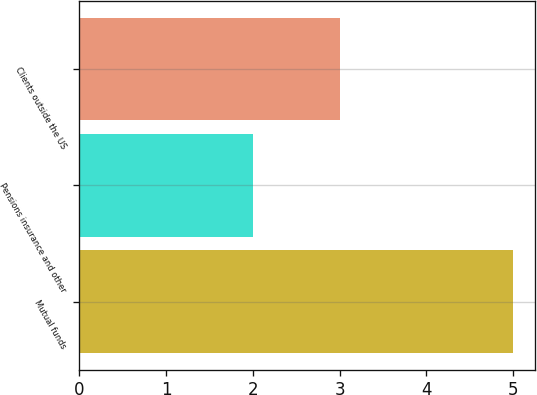<chart> <loc_0><loc_0><loc_500><loc_500><bar_chart><fcel>Mutual funds<fcel>Pensions insurance and other<fcel>Clients outside the US<nl><fcel>5<fcel>2<fcel>3<nl></chart> 